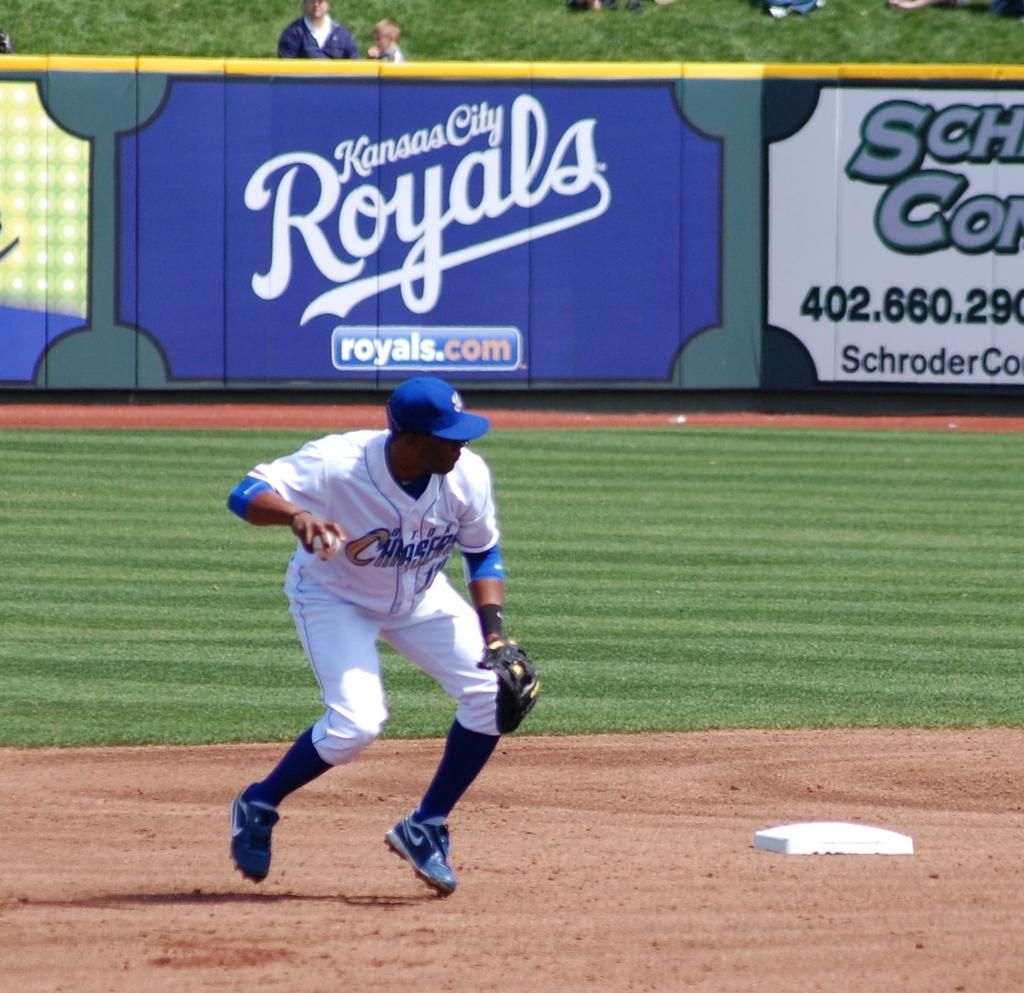<image>
Describe the image concisely. A baseball player for the Storm Chasers is near a base. 